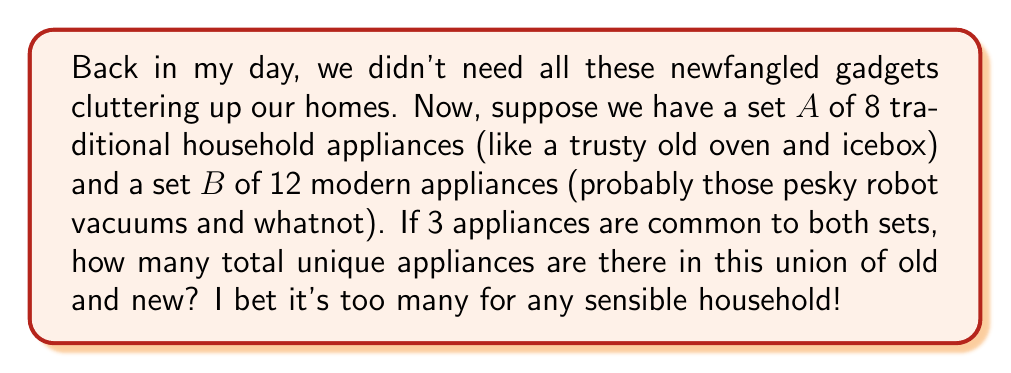Help me with this question. To solve this problem, we need to use the formula for the number of elements in the union of two sets:

$$ |A \cup B| = |A| + |B| - |A \cap B| $$

Where:
$|A \cup B|$ is the number of elements in the union of sets A and B
$|A|$ is the number of elements in set A
$|B|$ is the number of elements in set B
$|A \cap B|$ is the number of elements in the intersection of A and B

Given:
$|A| = 8$ (traditional appliances)
$|B| = 12$ (modern appliances)
$|A \cap B| = 3$ (appliances common to both sets)

Now, let's plug these values into our formula:

$$ |A \cup B| = 8 + 12 - 3 $$

$$ |A \cup B| = 20 - 3 $$

$$ |A \cup B| = 17 $$

This means there are 17 unique appliances in total when we combine the traditional and modern sets.
Answer: $17$ unique appliances 